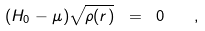Convert formula to latex. <formula><loc_0><loc_0><loc_500><loc_500>( H _ { 0 } - \mu ) \sqrt { \rho ( { r } ) } \ = \ 0 \quad ,</formula> 